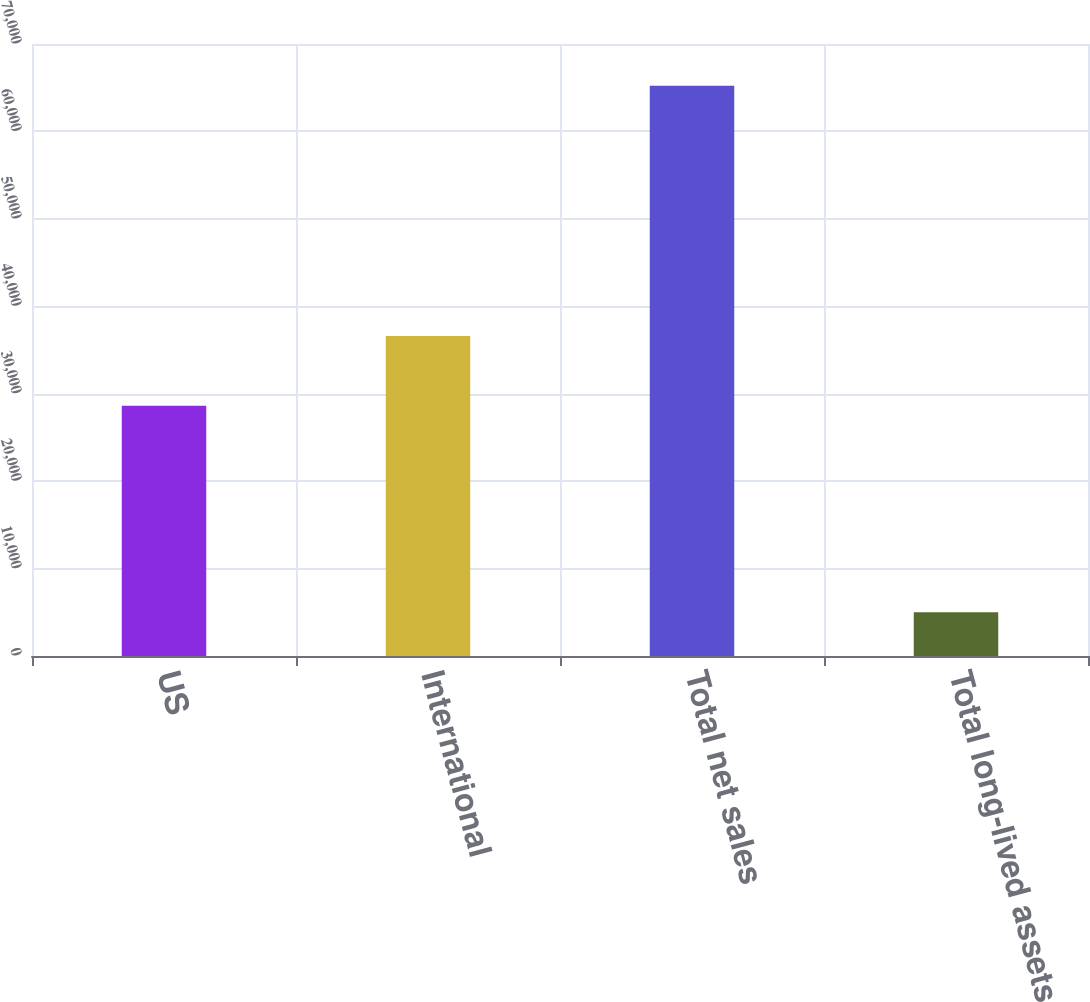<chart> <loc_0><loc_0><loc_500><loc_500><bar_chart><fcel>US<fcel>International<fcel>Total net sales<fcel>Total long-lived assets<nl><fcel>28633<fcel>36592<fcel>65225<fcel>5002<nl></chart> 